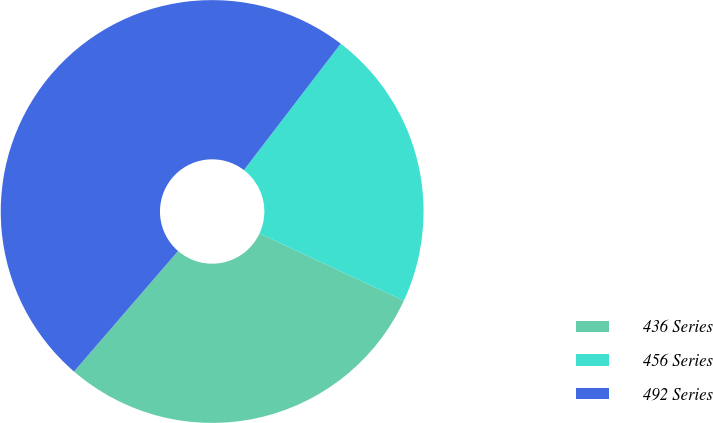<chart> <loc_0><loc_0><loc_500><loc_500><pie_chart><fcel>436 Series<fcel>456 Series<fcel>492 Series<nl><fcel>29.4%<fcel>21.53%<fcel>49.07%<nl></chart> 